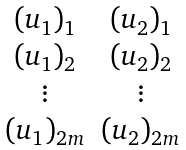Convert formula to latex. <formula><loc_0><loc_0><loc_500><loc_500>\begin{matrix} ( u _ { 1 } ) _ { 1 } & ( u _ { 2 } ) _ { 1 } \\ ( u _ { 1 } ) _ { 2 } & ( u _ { 2 } ) _ { 2 } \\ \vdots & \vdots \\ ( u _ { 1 } ) _ { 2 m } & ( u _ { 2 } ) _ { 2 m } \end{matrix}</formula> 